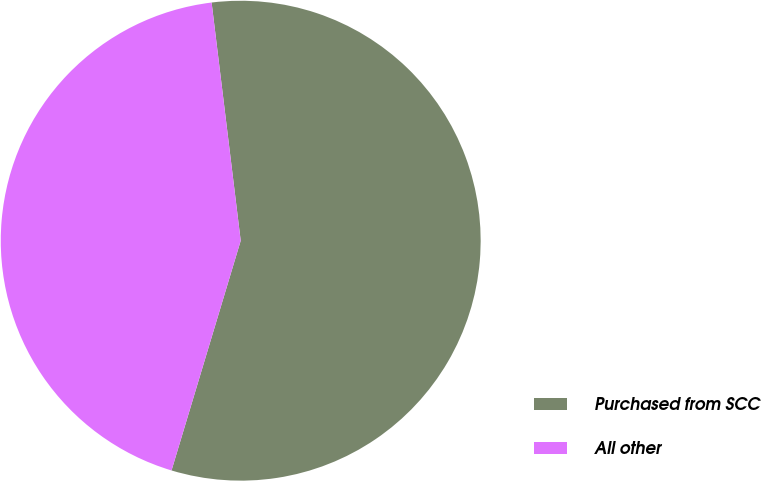Convert chart to OTSL. <chart><loc_0><loc_0><loc_500><loc_500><pie_chart><fcel>Purchased from SCC<fcel>All other<nl><fcel>56.59%<fcel>43.41%<nl></chart> 